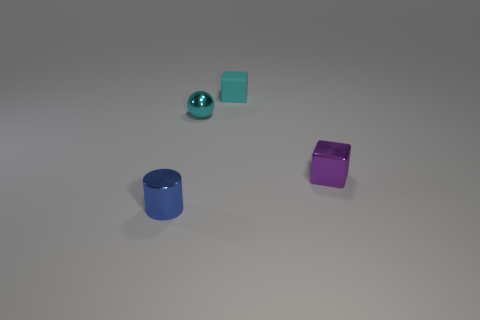Add 1 cubes. How many objects exist? 5 Subtract all spheres. How many objects are left? 3 Add 3 small blocks. How many small blocks exist? 5 Subtract 0 purple cylinders. How many objects are left? 4 Subtract all metal cylinders. Subtract all brown blocks. How many objects are left? 3 Add 2 cyan blocks. How many cyan blocks are left? 3 